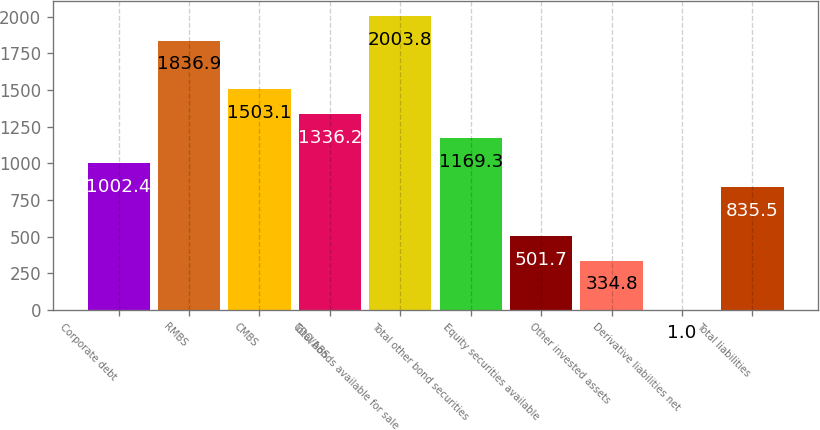Convert chart. <chart><loc_0><loc_0><loc_500><loc_500><bar_chart><fcel>Corporate debt<fcel>RMBS<fcel>CMBS<fcel>CDO/ABS<fcel>Total bonds available for sale<fcel>Total other bond securities<fcel>Equity securities available<fcel>Other invested assets<fcel>Derivative liabilities net<fcel>Total liabilities<nl><fcel>1002.4<fcel>1836.9<fcel>1503.1<fcel>1336.2<fcel>2003.8<fcel>1169.3<fcel>501.7<fcel>334.8<fcel>1<fcel>835.5<nl></chart> 